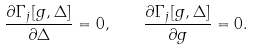Convert formula to latex. <formula><loc_0><loc_0><loc_500><loc_500>\frac { \partial \Gamma _ { j } [ g , \Delta ] } { \partial \Delta } = 0 , \quad \frac { \partial \Gamma _ { j } [ g , \Delta ] } { \partial g } = 0 .</formula> 